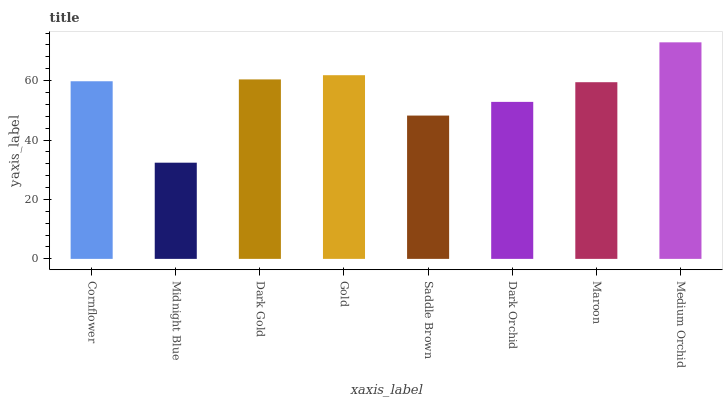Is Dark Gold the minimum?
Answer yes or no. No. Is Dark Gold the maximum?
Answer yes or no. No. Is Dark Gold greater than Midnight Blue?
Answer yes or no. Yes. Is Midnight Blue less than Dark Gold?
Answer yes or no. Yes. Is Midnight Blue greater than Dark Gold?
Answer yes or no. No. Is Dark Gold less than Midnight Blue?
Answer yes or no. No. Is Cornflower the high median?
Answer yes or no. Yes. Is Maroon the low median?
Answer yes or no. Yes. Is Gold the high median?
Answer yes or no. No. Is Gold the low median?
Answer yes or no. No. 